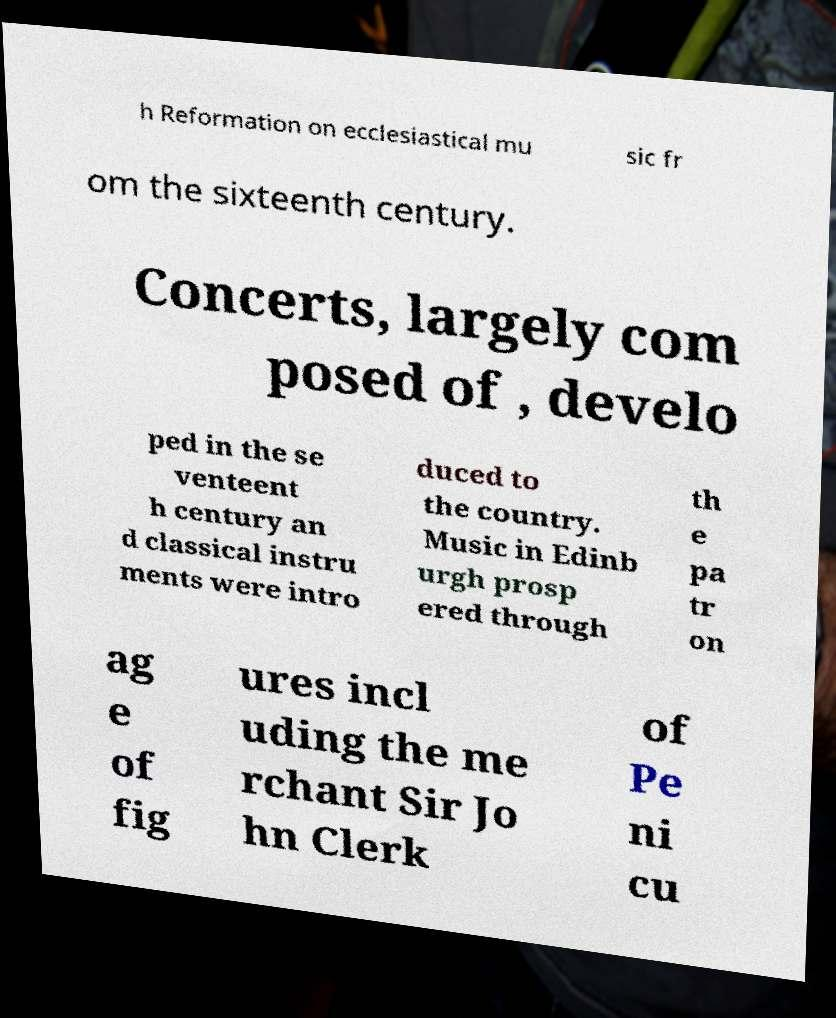What messages or text are displayed in this image? I need them in a readable, typed format. h Reformation on ecclesiastical mu sic fr om the sixteenth century. Concerts, largely com posed of , develo ped in the se venteent h century an d classical instru ments were intro duced to the country. Music in Edinb urgh prosp ered through th e pa tr on ag e of fig ures incl uding the me rchant Sir Jo hn Clerk of Pe ni cu 